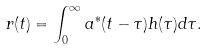<formula> <loc_0><loc_0><loc_500><loc_500>r ( t ) = \int _ { 0 } ^ { \infty } a ^ { * } ( t - \tau ) h ( \tau ) d \tau .</formula> 